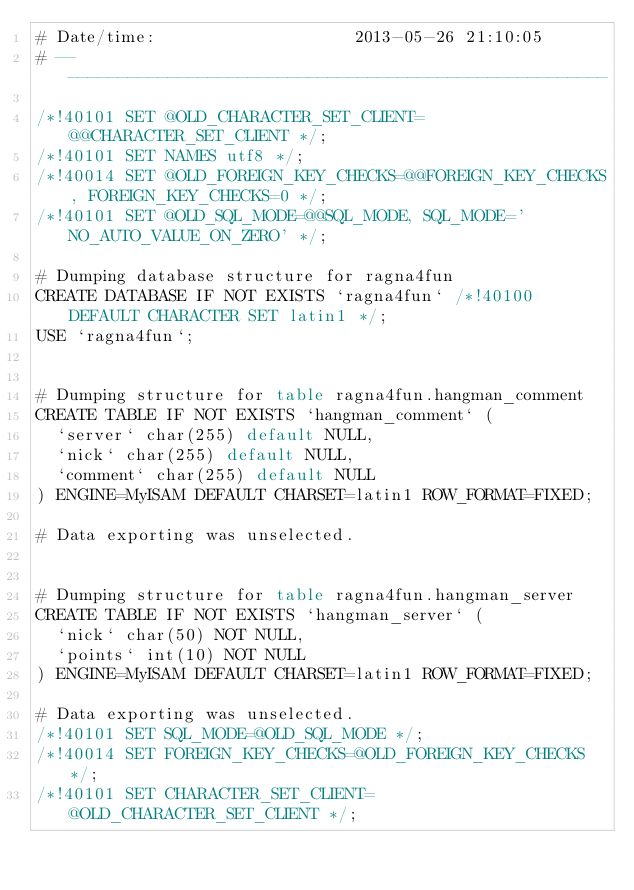<code> <loc_0><loc_0><loc_500><loc_500><_SQL_># Date/time:                    2013-05-26 21:10:05
# --------------------------------------------------------

/*!40101 SET @OLD_CHARACTER_SET_CLIENT=@@CHARACTER_SET_CLIENT */;
/*!40101 SET NAMES utf8 */;
/*!40014 SET @OLD_FOREIGN_KEY_CHECKS=@@FOREIGN_KEY_CHECKS, FOREIGN_KEY_CHECKS=0 */;
/*!40101 SET @OLD_SQL_MODE=@@SQL_MODE, SQL_MODE='NO_AUTO_VALUE_ON_ZERO' */;

# Dumping database structure for ragna4fun
CREATE DATABASE IF NOT EXISTS `ragna4fun` /*!40100 DEFAULT CHARACTER SET latin1 */;
USE `ragna4fun`;


# Dumping structure for table ragna4fun.hangman_comment
CREATE TABLE IF NOT EXISTS `hangman_comment` (
  `server` char(255) default NULL,
  `nick` char(255) default NULL,
  `comment` char(255) default NULL
) ENGINE=MyISAM DEFAULT CHARSET=latin1 ROW_FORMAT=FIXED;

# Data exporting was unselected.


# Dumping structure for table ragna4fun.hangman_server
CREATE TABLE IF NOT EXISTS `hangman_server` (
  `nick` char(50) NOT NULL,
  `points` int(10) NOT NULL
) ENGINE=MyISAM DEFAULT CHARSET=latin1 ROW_FORMAT=FIXED;

# Data exporting was unselected.
/*!40101 SET SQL_MODE=@OLD_SQL_MODE */;
/*!40014 SET FOREIGN_KEY_CHECKS=@OLD_FOREIGN_KEY_CHECKS */;
/*!40101 SET CHARACTER_SET_CLIENT=@OLD_CHARACTER_SET_CLIENT */;
</code> 